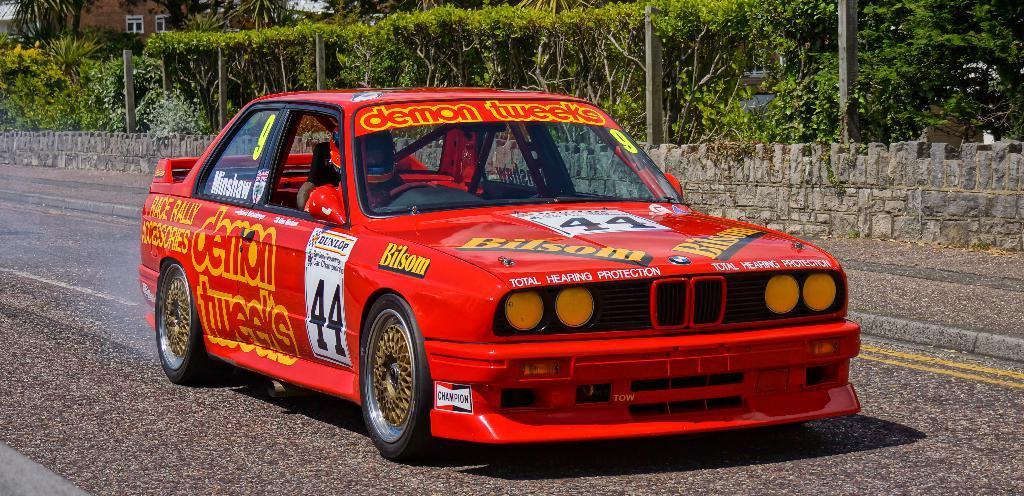How would you summarize this image in a sentence or two? In this image, in the middle, we can see a car which is placed on the road. In the car, we can see a person riding it. In the background, we can see some plants, trees. 